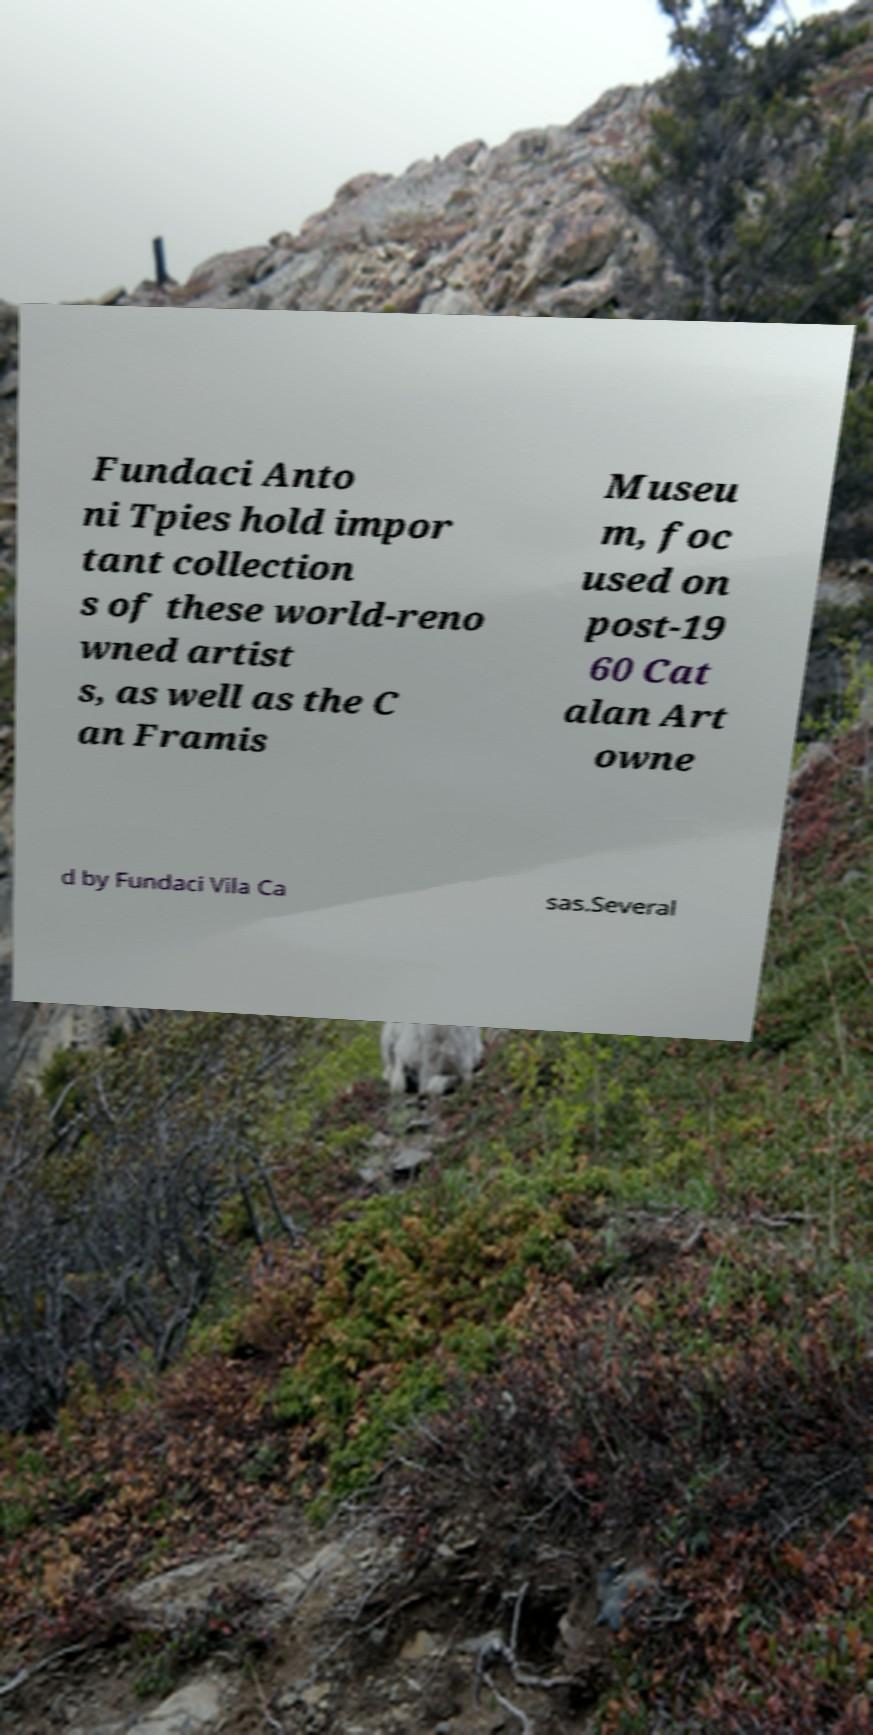Can you read and provide the text displayed in the image?This photo seems to have some interesting text. Can you extract and type it out for me? Fundaci Anto ni Tpies hold impor tant collection s of these world-reno wned artist s, as well as the C an Framis Museu m, foc used on post-19 60 Cat alan Art owne d by Fundaci Vila Ca sas.Several 